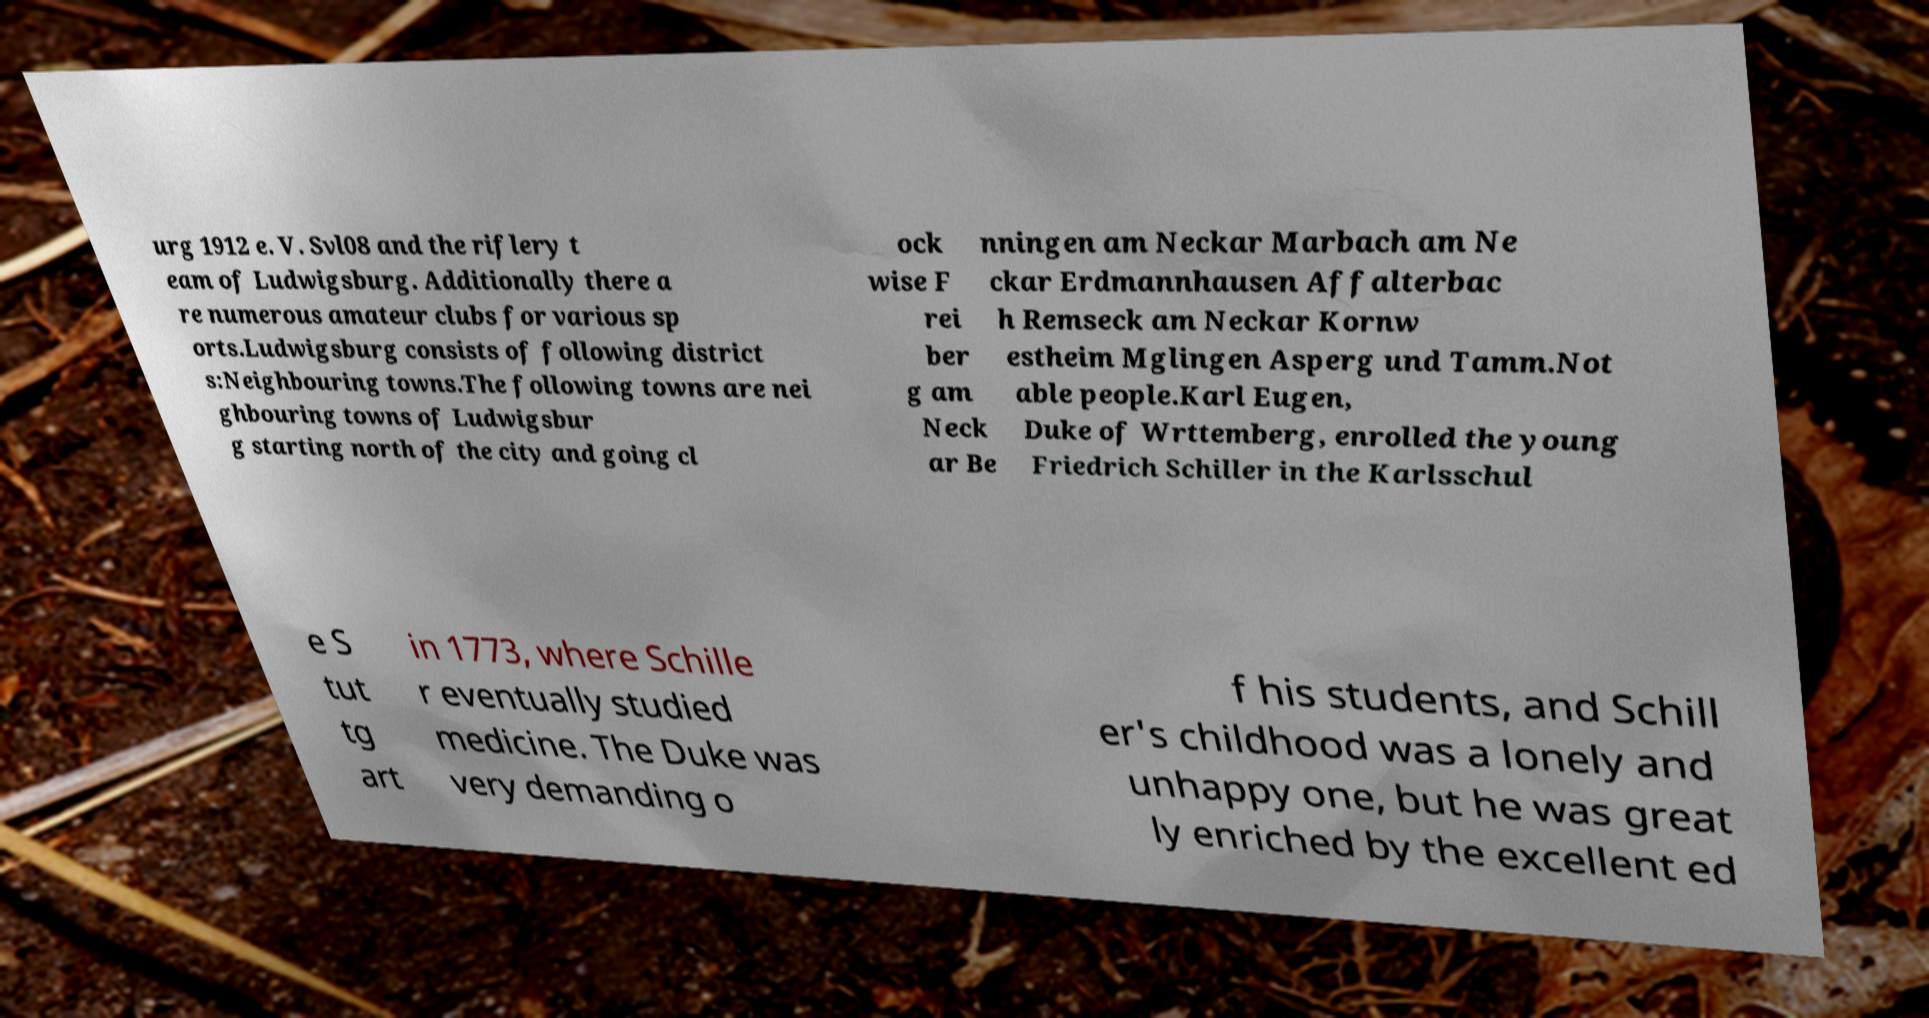I need the written content from this picture converted into text. Can you do that? urg 1912 e. V. Svl08 and the riflery t eam of Ludwigsburg. Additionally there a re numerous amateur clubs for various sp orts.Ludwigsburg consists of following district s:Neighbouring towns.The following towns are nei ghbouring towns of Ludwigsbur g starting north of the city and going cl ock wise F rei ber g am Neck ar Be nningen am Neckar Marbach am Ne ckar Erdmannhausen Affalterbac h Remseck am Neckar Kornw estheim Mglingen Asperg und Tamm.Not able people.Karl Eugen, Duke of Wrttemberg, enrolled the young Friedrich Schiller in the Karlsschul e S tut tg art in 1773, where Schille r eventually studied medicine. The Duke was very demanding o f his students, and Schill er's childhood was a lonely and unhappy one, but he was great ly enriched by the excellent ed 